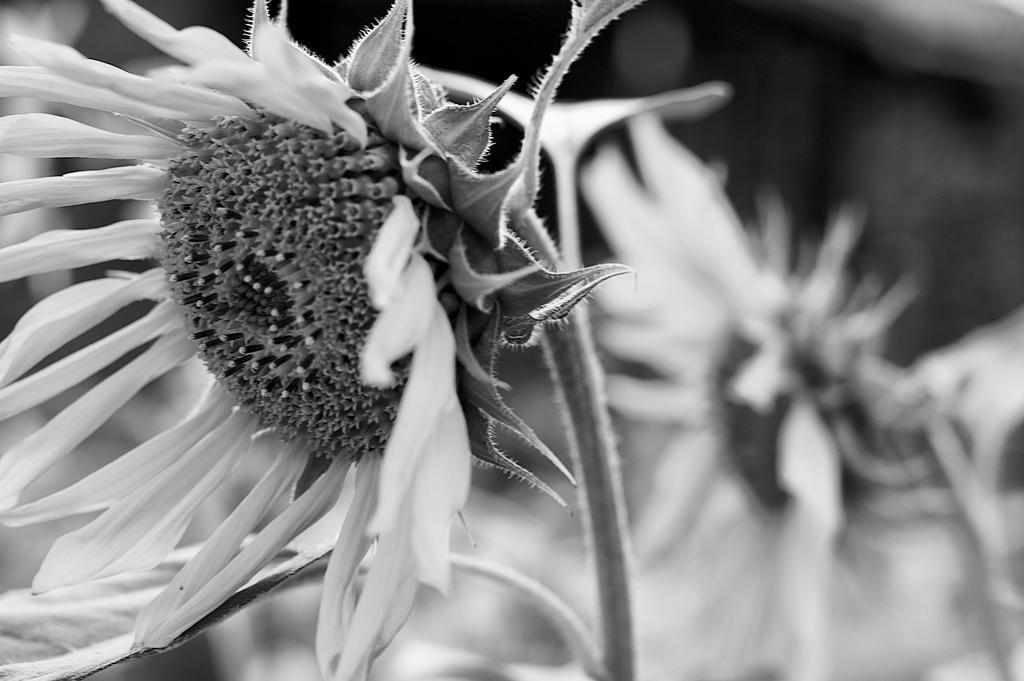How would you summarize this image in a sentence or two? This is the black and white image and we can see few flowers and in the background the image is blurred. 